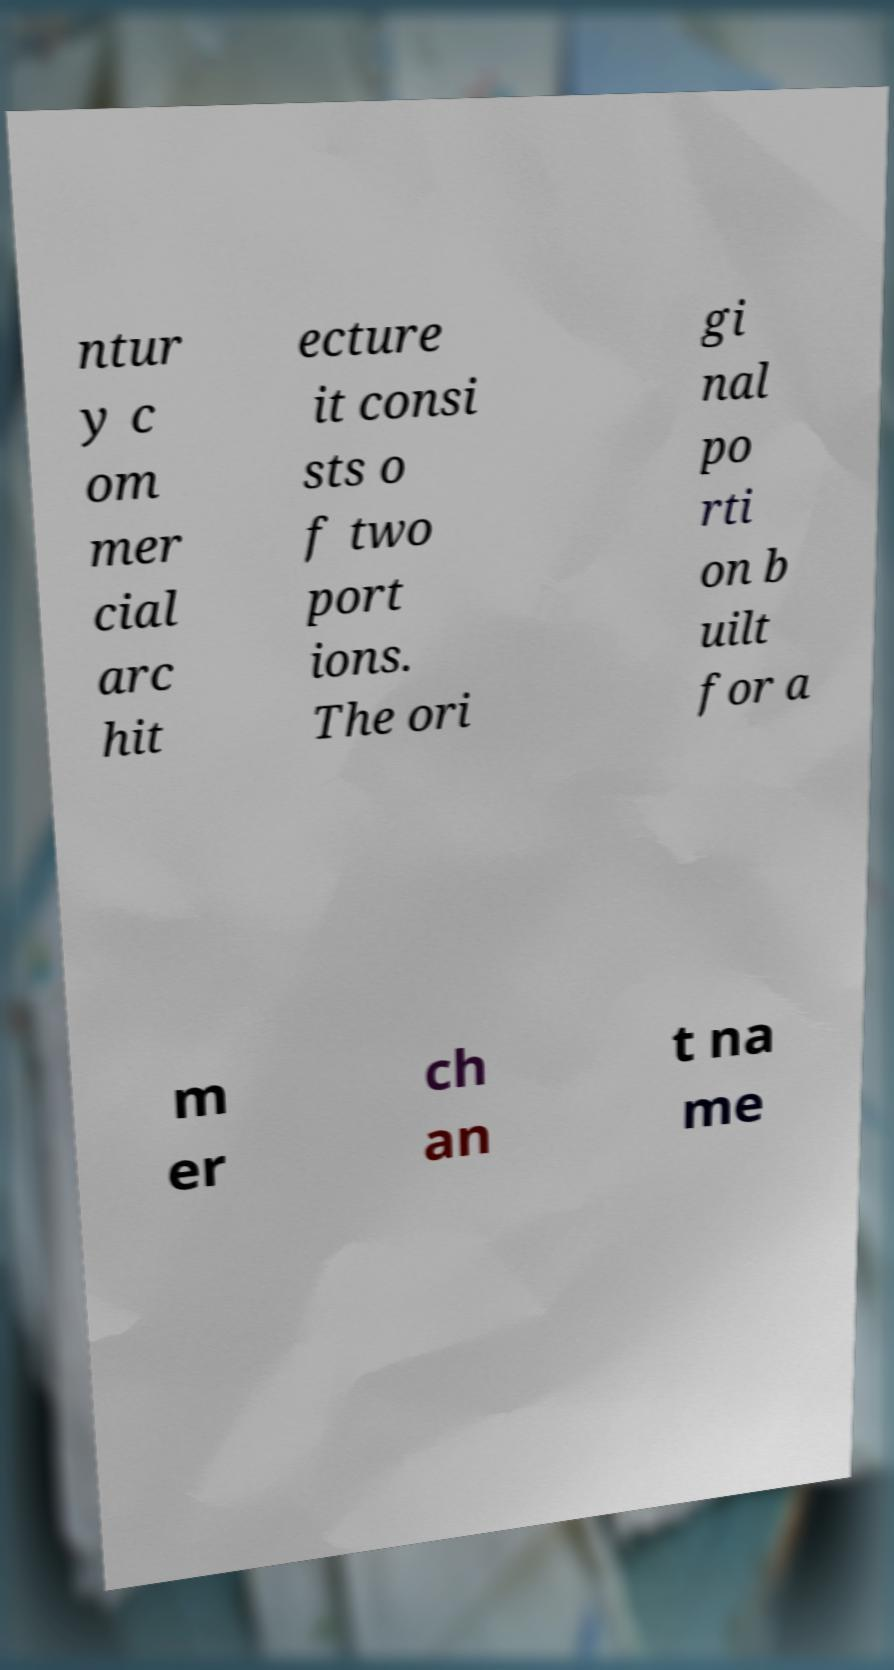For documentation purposes, I need the text within this image transcribed. Could you provide that? ntur y c om mer cial arc hit ecture it consi sts o f two port ions. The ori gi nal po rti on b uilt for a m er ch an t na me 